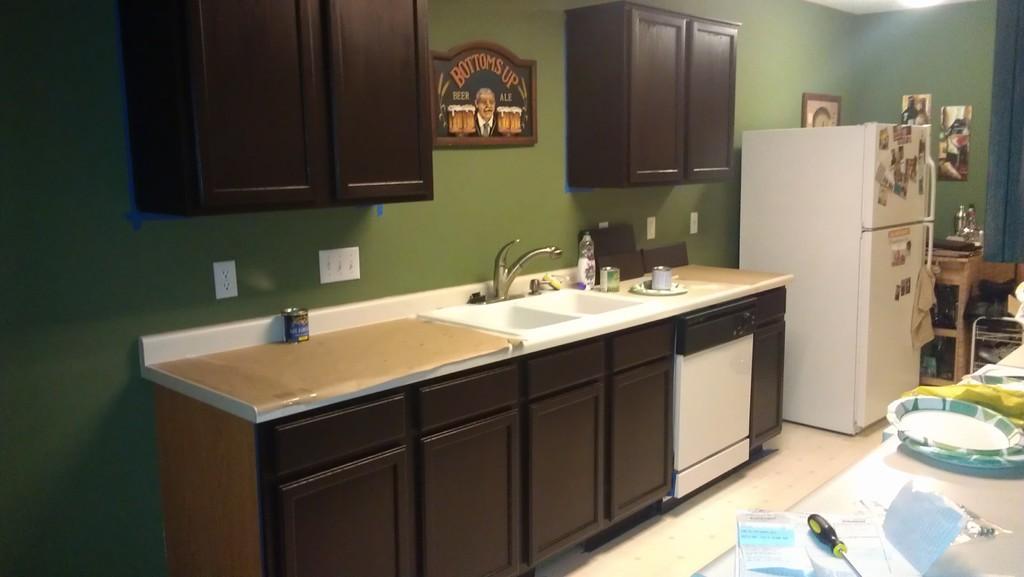How would you summarize this image in a sentence or two? In this image in front there is a platform. On top of it there are plates, papers and a few other objects. There are wooden cupboards. On top of it there is a sink. Beside the sink there are a few objects. There is a fridge and there are pins attached to the fridge. Beside the fridge there is a wooden table. On top of it there are few objects. There is a wall with photo frames on it. In the background of the image there are wooden cupboards attached to the wall. At the bottom of the image there is a floor. On top of the image there is a light. 